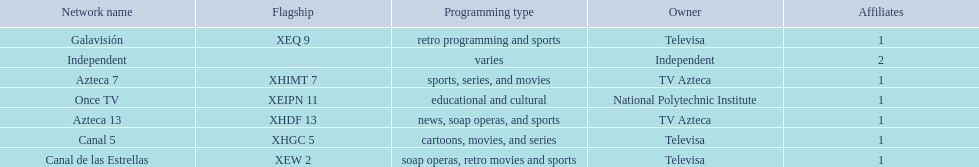How many networks does tv azteca own? 2. 